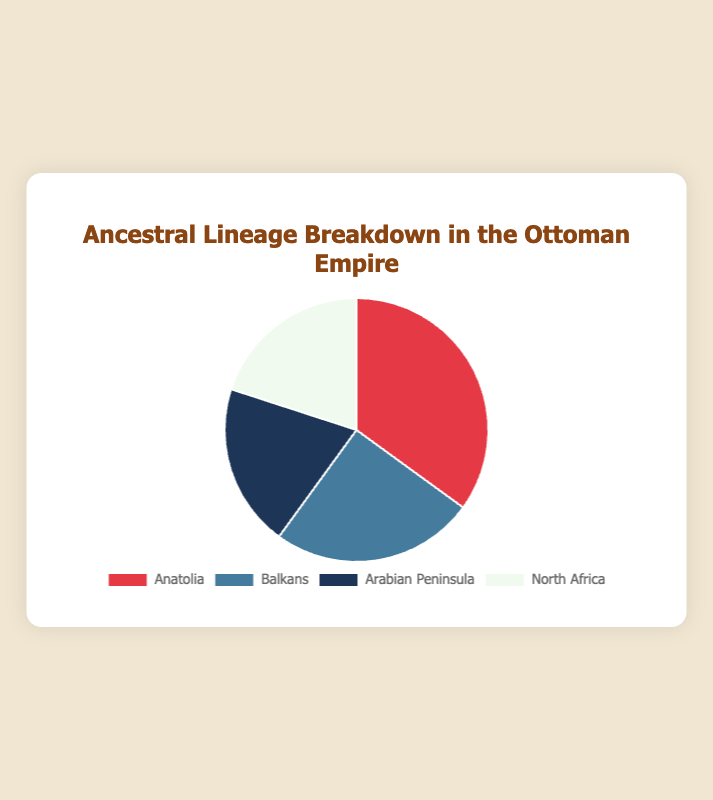What percentage of the ancestral lineage is attributed to the Arabian Peninsula? The pie chart shows that the Arabian Peninsula has a portion labeled with 20%.
Answer: 20% Which region has the largest ancestral lineage percentage? By identifying the largest section on the pie chart, we can observe that Anatolia has the largest percentage with 35%.
Answer: Anatolia What is the total percentage of ancestral lineage attributed to the Arabian Peninsula and North Africa combined? The chart shows that both the Arabian Peninsula and North Africa are 20% each. Summing them up gives 20% + 20% = 40%.
Answer: 40% How much more percentage does Anatolia have compared to the Balkans? The pie chart shows Anatolia at 35% and the Balkans at 25%. The difference is 35% - 25% = 10%.
Answer: 10% Which region shares the same ancestral lineage percentage in the pie chart? The chart indicates both the Arabian Peninsula and North Africa have 20% each.
Answer: Arabian Peninsula and North Africa What is the visual color associated with the Balkan region on the pie chart? Upon viewing the chart, it can be seen that the Balkans region is represented by a blue color.
Answer: Blue What is the percentage difference between the region with the highest and lowest ancestral lineage percentages? The highest percentage is in Anatolia at 35%, and the lowest among the sections is both Arabian Peninsula and North Africa at 20%. The difference is 35% - 20% = 15%.
Answer: 15% Which region comes after the highest percentage when ordered from highest to lowest ancestral lineage percentages? Following the highest percentage of Anatolia (35%), the next largest is the Balkans at 25%.
Answer: Balkans How many regions have an ancestral lineage percentage of 20%? By observing the pie chart, both the Arabian Peninsula and North Africa have 20% each, making it a total of 2 regions.
Answer: 2 If Anatolia and the Balkans combined their percentages, what portion of the whole would they represent? Summing the percentages of Anatolia (35%) and the Balkans (25%) results in 60%.
Answer: 60% 